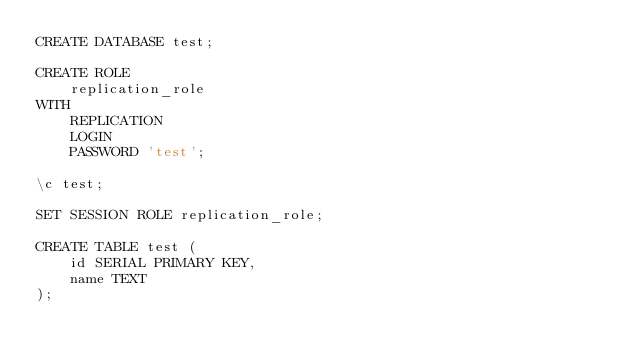<code> <loc_0><loc_0><loc_500><loc_500><_SQL_>CREATE DATABASE test;

CREATE ROLE
    replication_role
WITH
    REPLICATION
    LOGIN
    PASSWORD 'test';

\c test;

SET SESSION ROLE replication_role;

CREATE TABLE test (
    id SERIAL PRIMARY KEY,
    name TEXT
);
</code> 